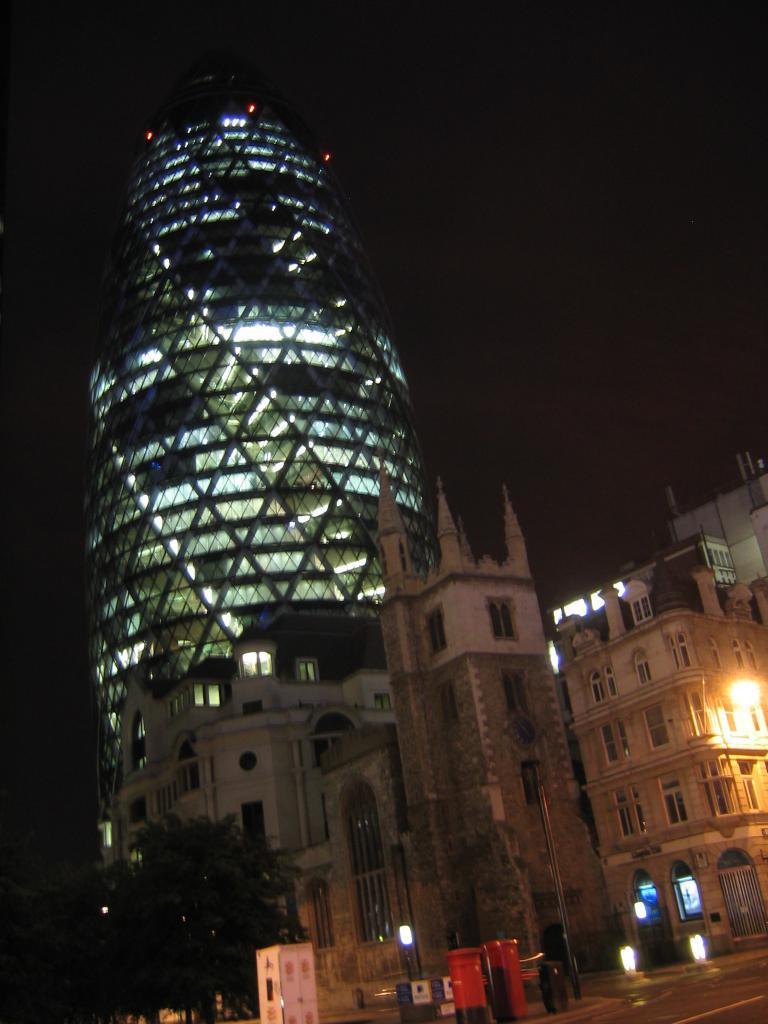Describe this image in one or two sentences. In this picture we can see the road, post box, booth, lights, trees, buildings with windows and some objects and in the background it is dark. 